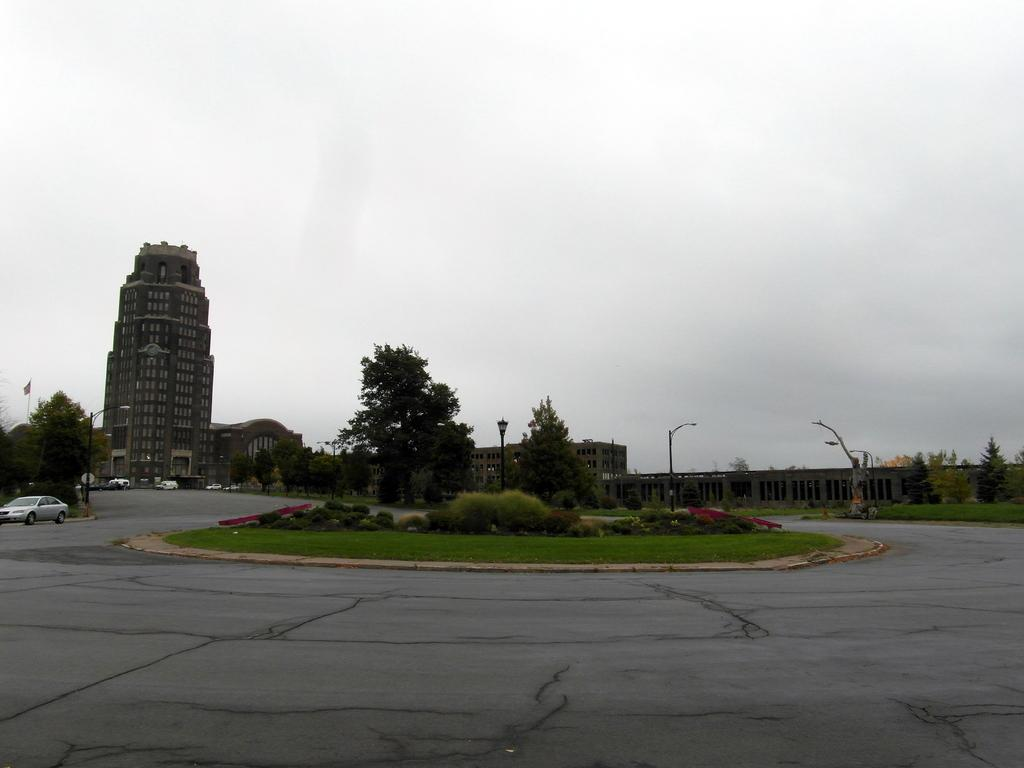What type of vegetation can be seen in the image? There are trees in the image. What color are the trees? The trees are green. What else can be seen on the ground in the image? There are vehicles on the road in the image. What structures are present along the road? Light poles are visible in the image. What is visible in the background of the image? There is a building in the background of the image. What is the color of the sky in the image? The sky is white in the image. What type of oven can be seen in the image? There is no oven present in the image. How does the sock move around in the image? There is no sock present in the image, so it cannot move around. 